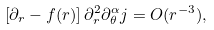Convert formula to latex. <formula><loc_0><loc_0><loc_500><loc_500>\left [ \partial _ { r } - f ( r ) \right ] \partial _ { r } ^ { 2 } \partial _ { \theta } ^ { \alpha } j = O ( r ^ { - 3 } ) ,</formula> 